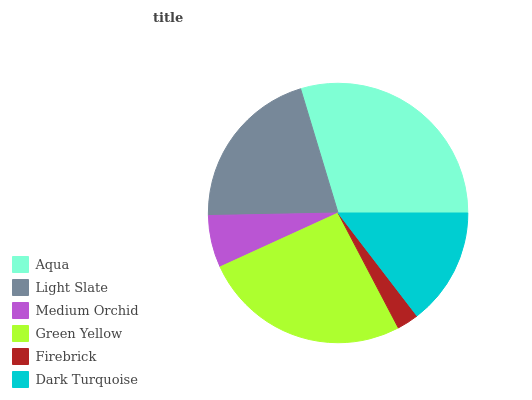Is Firebrick the minimum?
Answer yes or no. Yes. Is Aqua the maximum?
Answer yes or no. Yes. Is Light Slate the minimum?
Answer yes or no. No. Is Light Slate the maximum?
Answer yes or no. No. Is Aqua greater than Light Slate?
Answer yes or no. Yes. Is Light Slate less than Aqua?
Answer yes or no. Yes. Is Light Slate greater than Aqua?
Answer yes or no. No. Is Aqua less than Light Slate?
Answer yes or no. No. Is Light Slate the high median?
Answer yes or no. Yes. Is Dark Turquoise the low median?
Answer yes or no. Yes. Is Green Yellow the high median?
Answer yes or no. No. Is Firebrick the low median?
Answer yes or no. No. 